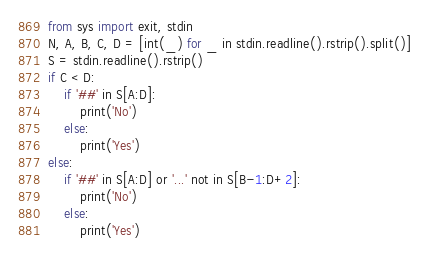<code> <loc_0><loc_0><loc_500><loc_500><_Python_>from sys import exit, stdin
N, A, B, C, D = [int(_) for _ in stdin.readline().rstrip().split()]
S = stdin.readline().rstrip()
if C < D:
    if '##' in S[A:D]:
        print('No')
    else:
        print('Yes')
else:
    if '##' in S[A:D] or '...' not in S[B-1:D+2]:
        print('No')
    else:
        print('Yes')</code> 